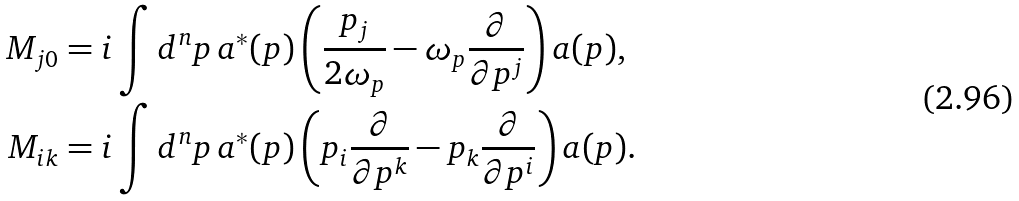<formula> <loc_0><loc_0><loc_500><loc_500>M _ { j 0 } & = i \int d ^ { n } p \, { a } ^ { * } ( p ) \left ( \frac { p _ { j } } { 2 \omega _ { p } } - \omega _ { p } \frac { \partial } { \partial p ^ { j } } \right ) a ( p ) , \\ M _ { i k } & = i \int d ^ { n } p \, { a } ^ { * } ( p ) \left ( p _ { i } \frac { \partial } { \partial p ^ { k } } - p _ { k } \frac { \partial } { \partial p ^ { i } } \right ) a ( p ) .</formula> 